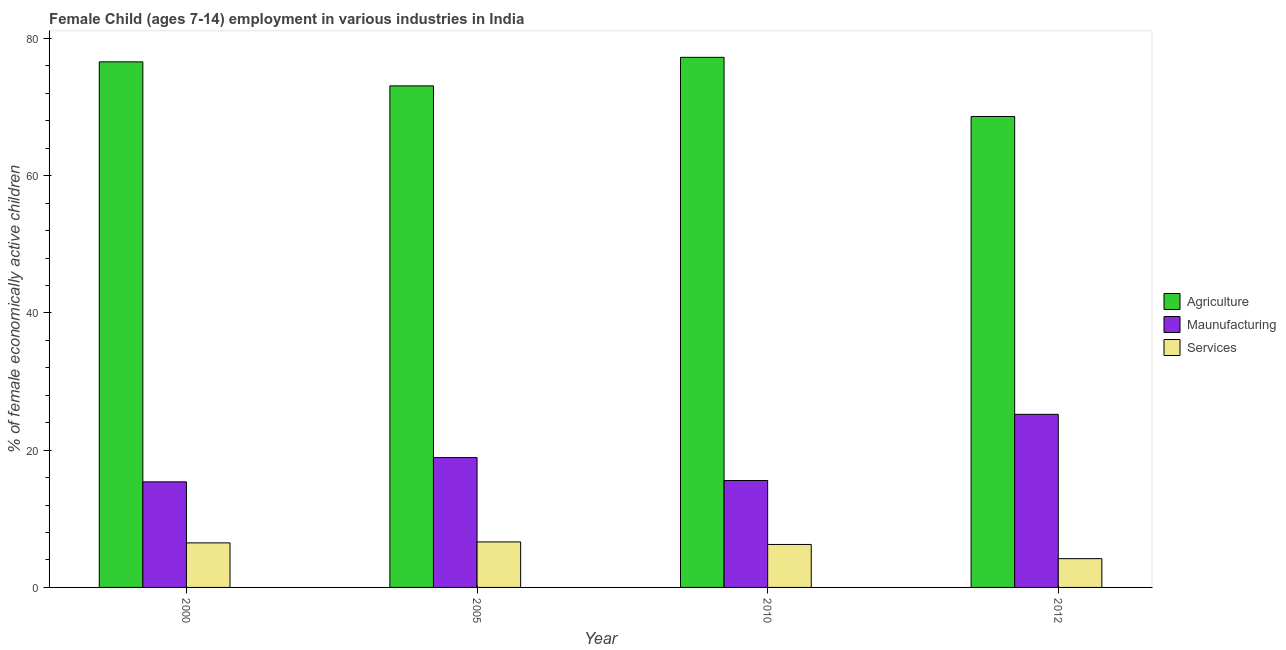How many groups of bars are there?
Provide a succinct answer. 4. How many bars are there on the 2nd tick from the left?
Your answer should be compact. 3. In how many cases, is the number of bars for a given year not equal to the number of legend labels?
Give a very brief answer. 0. What is the percentage of economically active children in manufacturing in 2012?
Keep it short and to the point. 25.22. Across all years, what is the maximum percentage of economically active children in agriculture?
Give a very brief answer. 77.24. Across all years, what is the minimum percentage of economically active children in agriculture?
Make the answer very short. 68.62. What is the total percentage of economically active children in agriculture in the graph?
Keep it short and to the point. 295.52. What is the difference between the percentage of economically active children in manufacturing in 2010 and that in 2012?
Provide a short and direct response. -9.64. What is the difference between the percentage of economically active children in manufacturing in 2010 and the percentage of economically active children in services in 2005?
Keep it short and to the point. -3.34. What is the average percentage of economically active children in services per year?
Your answer should be very brief. 5.89. In how many years, is the percentage of economically active children in services greater than 12 %?
Offer a very short reply. 0. What is the ratio of the percentage of economically active children in services in 2000 to that in 2010?
Offer a terse response. 1.04. What is the difference between the highest and the second highest percentage of economically active children in agriculture?
Ensure brevity in your answer.  0.66. What is the difference between the highest and the lowest percentage of economically active children in services?
Provide a succinct answer. 2.44. In how many years, is the percentage of economically active children in services greater than the average percentage of economically active children in services taken over all years?
Provide a short and direct response. 3. Is the sum of the percentage of economically active children in manufacturing in 2005 and 2010 greater than the maximum percentage of economically active children in agriculture across all years?
Offer a very short reply. Yes. What does the 1st bar from the left in 2000 represents?
Keep it short and to the point. Agriculture. What does the 3rd bar from the right in 2000 represents?
Offer a very short reply. Agriculture. Is it the case that in every year, the sum of the percentage of economically active children in agriculture and percentage of economically active children in manufacturing is greater than the percentage of economically active children in services?
Offer a terse response. Yes. Are all the bars in the graph horizontal?
Offer a terse response. No. What is the difference between two consecutive major ticks on the Y-axis?
Provide a short and direct response. 20. Does the graph contain any zero values?
Give a very brief answer. No. Does the graph contain grids?
Your answer should be very brief. No. How are the legend labels stacked?
Keep it short and to the point. Vertical. What is the title of the graph?
Your answer should be very brief. Female Child (ages 7-14) employment in various industries in India. Does "Domestic economy" appear as one of the legend labels in the graph?
Your answer should be compact. No. What is the label or title of the X-axis?
Offer a very short reply. Year. What is the label or title of the Y-axis?
Make the answer very short. % of female economically active children. What is the % of female economically active children in Agriculture in 2000?
Provide a short and direct response. 76.58. What is the % of female economically active children in Maunufacturing in 2000?
Make the answer very short. 15.38. What is the % of female economically active children of Services in 2000?
Give a very brief answer. 6.49. What is the % of female economically active children in Agriculture in 2005?
Your answer should be very brief. 73.08. What is the % of female economically active children of Maunufacturing in 2005?
Provide a succinct answer. 18.92. What is the % of female economically active children in Services in 2005?
Offer a very short reply. 6.63. What is the % of female economically active children in Agriculture in 2010?
Ensure brevity in your answer.  77.24. What is the % of female economically active children of Maunufacturing in 2010?
Provide a short and direct response. 15.58. What is the % of female economically active children in Services in 2010?
Offer a very short reply. 6.26. What is the % of female economically active children in Agriculture in 2012?
Offer a very short reply. 68.62. What is the % of female economically active children of Maunufacturing in 2012?
Offer a very short reply. 25.22. What is the % of female economically active children of Services in 2012?
Provide a succinct answer. 4.19. Across all years, what is the maximum % of female economically active children in Agriculture?
Provide a succinct answer. 77.24. Across all years, what is the maximum % of female economically active children in Maunufacturing?
Your answer should be very brief. 25.22. Across all years, what is the maximum % of female economically active children of Services?
Provide a succinct answer. 6.63. Across all years, what is the minimum % of female economically active children in Agriculture?
Your answer should be very brief. 68.62. Across all years, what is the minimum % of female economically active children in Maunufacturing?
Provide a short and direct response. 15.38. Across all years, what is the minimum % of female economically active children of Services?
Your answer should be compact. 4.19. What is the total % of female economically active children in Agriculture in the graph?
Your response must be concise. 295.52. What is the total % of female economically active children in Maunufacturing in the graph?
Your response must be concise. 75.1. What is the total % of female economically active children of Services in the graph?
Provide a short and direct response. 23.57. What is the difference between the % of female economically active children of Agriculture in 2000 and that in 2005?
Provide a succinct answer. 3.5. What is the difference between the % of female economically active children in Maunufacturing in 2000 and that in 2005?
Your answer should be compact. -3.54. What is the difference between the % of female economically active children in Services in 2000 and that in 2005?
Offer a terse response. -0.14. What is the difference between the % of female economically active children of Agriculture in 2000 and that in 2010?
Offer a terse response. -0.66. What is the difference between the % of female economically active children of Maunufacturing in 2000 and that in 2010?
Keep it short and to the point. -0.2. What is the difference between the % of female economically active children in Services in 2000 and that in 2010?
Your answer should be very brief. 0.23. What is the difference between the % of female economically active children in Agriculture in 2000 and that in 2012?
Offer a very short reply. 7.96. What is the difference between the % of female economically active children in Maunufacturing in 2000 and that in 2012?
Keep it short and to the point. -9.84. What is the difference between the % of female economically active children in Agriculture in 2005 and that in 2010?
Keep it short and to the point. -4.16. What is the difference between the % of female economically active children of Maunufacturing in 2005 and that in 2010?
Ensure brevity in your answer.  3.34. What is the difference between the % of female economically active children in Services in 2005 and that in 2010?
Give a very brief answer. 0.37. What is the difference between the % of female economically active children of Agriculture in 2005 and that in 2012?
Offer a very short reply. 4.46. What is the difference between the % of female economically active children in Maunufacturing in 2005 and that in 2012?
Your response must be concise. -6.3. What is the difference between the % of female economically active children of Services in 2005 and that in 2012?
Give a very brief answer. 2.44. What is the difference between the % of female economically active children in Agriculture in 2010 and that in 2012?
Make the answer very short. 8.62. What is the difference between the % of female economically active children in Maunufacturing in 2010 and that in 2012?
Your answer should be compact. -9.64. What is the difference between the % of female economically active children in Services in 2010 and that in 2012?
Your answer should be very brief. 2.07. What is the difference between the % of female economically active children of Agriculture in 2000 and the % of female economically active children of Maunufacturing in 2005?
Provide a succinct answer. 57.66. What is the difference between the % of female economically active children of Agriculture in 2000 and the % of female economically active children of Services in 2005?
Your response must be concise. 69.95. What is the difference between the % of female economically active children in Maunufacturing in 2000 and the % of female economically active children in Services in 2005?
Provide a succinct answer. 8.75. What is the difference between the % of female economically active children of Agriculture in 2000 and the % of female economically active children of Maunufacturing in 2010?
Offer a terse response. 61. What is the difference between the % of female economically active children in Agriculture in 2000 and the % of female economically active children in Services in 2010?
Give a very brief answer. 70.32. What is the difference between the % of female economically active children in Maunufacturing in 2000 and the % of female economically active children in Services in 2010?
Your answer should be very brief. 9.12. What is the difference between the % of female economically active children of Agriculture in 2000 and the % of female economically active children of Maunufacturing in 2012?
Keep it short and to the point. 51.36. What is the difference between the % of female economically active children in Agriculture in 2000 and the % of female economically active children in Services in 2012?
Your answer should be very brief. 72.39. What is the difference between the % of female economically active children in Maunufacturing in 2000 and the % of female economically active children in Services in 2012?
Keep it short and to the point. 11.19. What is the difference between the % of female economically active children of Agriculture in 2005 and the % of female economically active children of Maunufacturing in 2010?
Ensure brevity in your answer.  57.5. What is the difference between the % of female economically active children in Agriculture in 2005 and the % of female economically active children in Services in 2010?
Keep it short and to the point. 66.82. What is the difference between the % of female economically active children of Maunufacturing in 2005 and the % of female economically active children of Services in 2010?
Give a very brief answer. 12.66. What is the difference between the % of female economically active children in Agriculture in 2005 and the % of female economically active children in Maunufacturing in 2012?
Your response must be concise. 47.86. What is the difference between the % of female economically active children of Agriculture in 2005 and the % of female economically active children of Services in 2012?
Your response must be concise. 68.89. What is the difference between the % of female economically active children of Maunufacturing in 2005 and the % of female economically active children of Services in 2012?
Your answer should be compact. 14.73. What is the difference between the % of female economically active children of Agriculture in 2010 and the % of female economically active children of Maunufacturing in 2012?
Your answer should be very brief. 52.02. What is the difference between the % of female economically active children in Agriculture in 2010 and the % of female economically active children in Services in 2012?
Keep it short and to the point. 73.05. What is the difference between the % of female economically active children of Maunufacturing in 2010 and the % of female economically active children of Services in 2012?
Keep it short and to the point. 11.39. What is the average % of female economically active children of Agriculture per year?
Offer a terse response. 73.88. What is the average % of female economically active children of Maunufacturing per year?
Offer a very short reply. 18.77. What is the average % of female economically active children in Services per year?
Your response must be concise. 5.89. In the year 2000, what is the difference between the % of female economically active children of Agriculture and % of female economically active children of Maunufacturing?
Your response must be concise. 61.2. In the year 2000, what is the difference between the % of female economically active children of Agriculture and % of female economically active children of Services?
Your answer should be compact. 70.09. In the year 2000, what is the difference between the % of female economically active children in Maunufacturing and % of female economically active children in Services?
Ensure brevity in your answer.  8.89. In the year 2005, what is the difference between the % of female economically active children in Agriculture and % of female economically active children in Maunufacturing?
Your answer should be very brief. 54.16. In the year 2005, what is the difference between the % of female economically active children of Agriculture and % of female economically active children of Services?
Provide a succinct answer. 66.45. In the year 2005, what is the difference between the % of female economically active children of Maunufacturing and % of female economically active children of Services?
Provide a short and direct response. 12.29. In the year 2010, what is the difference between the % of female economically active children of Agriculture and % of female economically active children of Maunufacturing?
Provide a short and direct response. 61.66. In the year 2010, what is the difference between the % of female economically active children of Agriculture and % of female economically active children of Services?
Make the answer very short. 70.98. In the year 2010, what is the difference between the % of female economically active children of Maunufacturing and % of female economically active children of Services?
Your response must be concise. 9.32. In the year 2012, what is the difference between the % of female economically active children in Agriculture and % of female economically active children in Maunufacturing?
Provide a succinct answer. 43.4. In the year 2012, what is the difference between the % of female economically active children of Agriculture and % of female economically active children of Services?
Ensure brevity in your answer.  64.43. In the year 2012, what is the difference between the % of female economically active children of Maunufacturing and % of female economically active children of Services?
Provide a succinct answer. 21.03. What is the ratio of the % of female economically active children of Agriculture in 2000 to that in 2005?
Provide a short and direct response. 1.05. What is the ratio of the % of female economically active children in Maunufacturing in 2000 to that in 2005?
Make the answer very short. 0.81. What is the ratio of the % of female economically active children of Services in 2000 to that in 2005?
Make the answer very short. 0.98. What is the ratio of the % of female economically active children in Maunufacturing in 2000 to that in 2010?
Your answer should be compact. 0.99. What is the ratio of the % of female economically active children in Services in 2000 to that in 2010?
Offer a terse response. 1.04. What is the ratio of the % of female economically active children in Agriculture in 2000 to that in 2012?
Keep it short and to the point. 1.12. What is the ratio of the % of female economically active children in Maunufacturing in 2000 to that in 2012?
Provide a succinct answer. 0.61. What is the ratio of the % of female economically active children in Services in 2000 to that in 2012?
Make the answer very short. 1.55. What is the ratio of the % of female economically active children in Agriculture in 2005 to that in 2010?
Offer a very short reply. 0.95. What is the ratio of the % of female economically active children in Maunufacturing in 2005 to that in 2010?
Provide a succinct answer. 1.21. What is the ratio of the % of female economically active children of Services in 2005 to that in 2010?
Give a very brief answer. 1.06. What is the ratio of the % of female economically active children in Agriculture in 2005 to that in 2012?
Make the answer very short. 1.06. What is the ratio of the % of female economically active children of Maunufacturing in 2005 to that in 2012?
Provide a succinct answer. 0.75. What is the ratio of the % of female economically active children of Services in 2005 to that in 2012?
Offer a terse response. 1.58. What is the ratio of the % of female economically active children of Agriculture in 2010 to that in 2012?
Ensure brevity in your answer.  1.13. What is the ratio of the % of female economically active children in Maunufacturing in 2010 to that in 2012?
Offer a very short reply. 0.62. What is the ratio of the % of female economically active children of Services in 2010 to that in 2012?
Your answer should be compact. 1.49. What is the difference between the highest and the second highest % of female economically active children of Agriculture?
Make the answer very short. 0.66. What is the difference between the highest and the second highest % of female economically active children of Maunufacturing?
Offer a very short reply. 6.3. What is the difference between the highest and the second highest % of female economically active children of Services?
Make the answer very short. 0.14. What is the difference between the highest and the lowest % of female economically active children of Agriculture?
Ensure brevity in your answer.  8.62. What is the difference between the highest and the lowest % of female economically active children in Maunufacturing?
Provide a succinct answer. 9.84. What is the difference between the highest and the lowest % of female economically active children of Services?
Make the answer very short. 2.44. 